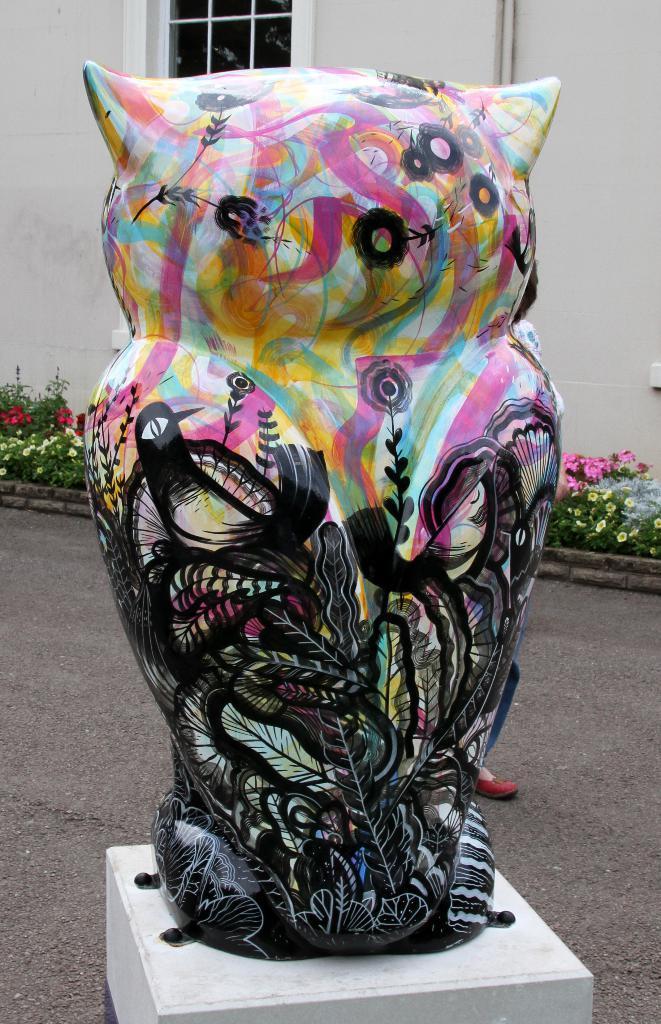Describe this image in one or two sentences. There are many plants in the image. There is a sculpture which placed on the an object. There is a house in the background of the image. 